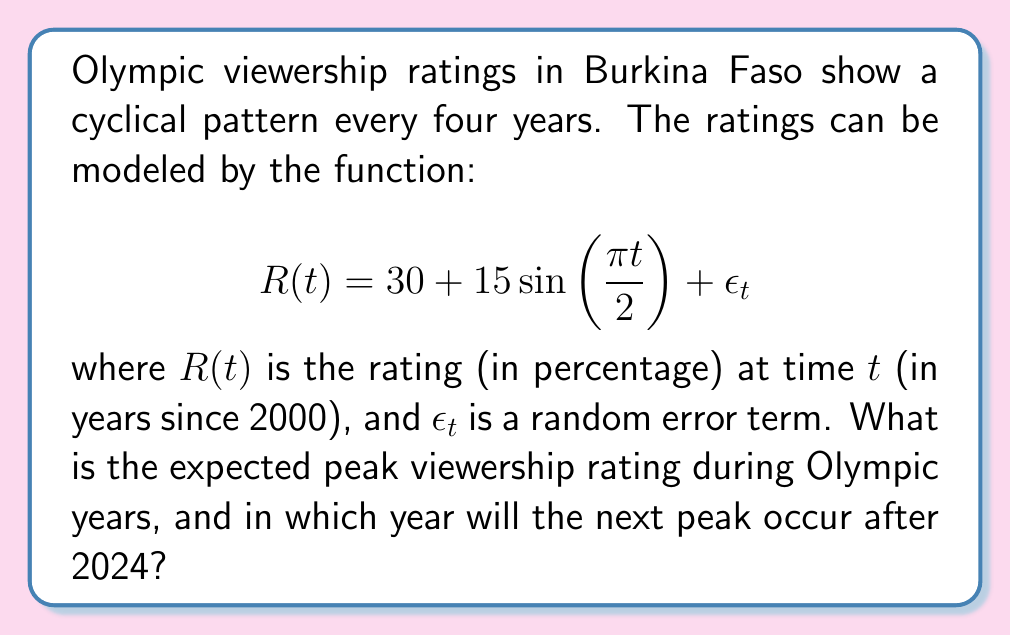Show me your answer to this math problem. To solve this problem, we need to follow these steps:

1) The sine function in the model represents the cyclical pattern. Its period is 4 years, which matches the Olympic cycle.

2) To find the peak viewership, we need to determine when the sine function reaches its maximum value. This occurs when:

   $$\frac{\pi t}{2} = \frac{\pi}{2} + 2\pi n, \quad n = 0, 1, 2, ...$$

3) Solving for $t$:

   $$t = 1 + 4n, \quad n = 0, 1, 2, ...$$

   This confirms that peaks occur every 4 years, starting from 2001 (1 year after 2000).

4) At these peak times, $\sin\left(\frac{\pi t}{2}\right) = 1$, so the expected peak rating is:

   $$R_{peak} = 30 + 15(1) = 45\%$$

5) To find the next peak after 2024:
   - 2024 corresponds to $t = 24$ (24 years after 2000)
   - The next peak will be at $t = 25$, which is 2025

Therefore, the next peak after 2024 will occur in 2025.
Answer: The expected peak viewership rating during Olympic years is 45%. The next peak after 2024 will occur in 2025. 